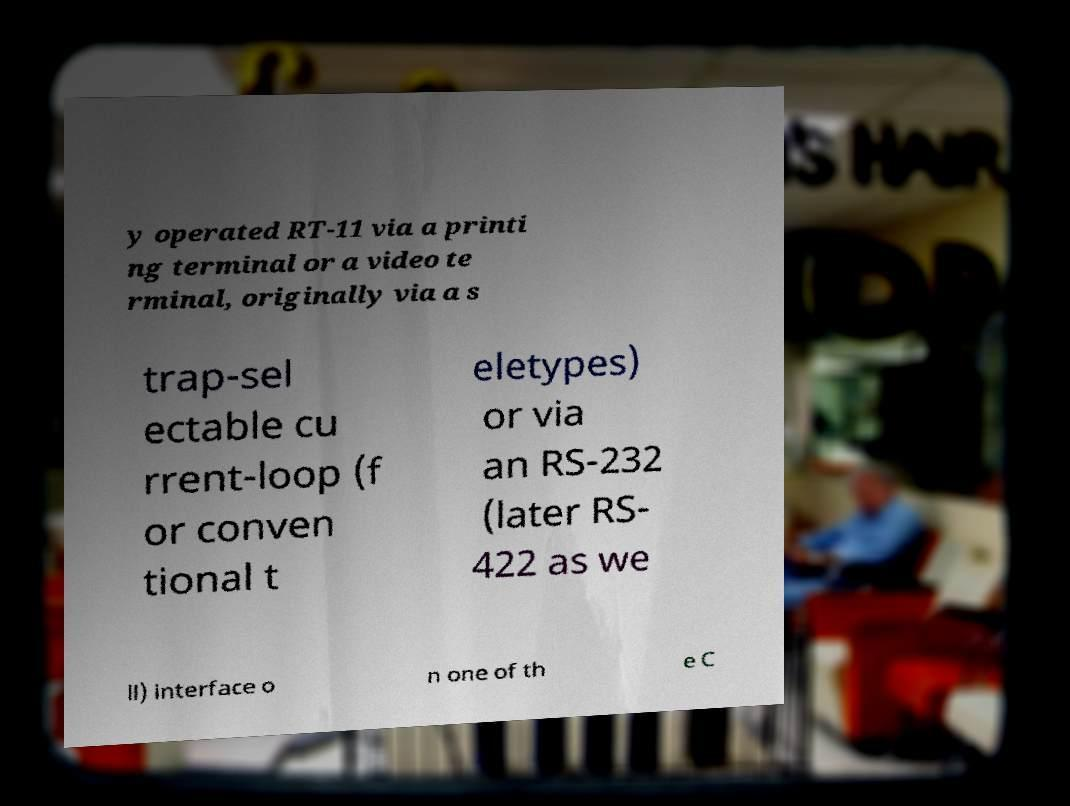There's text embedded in this image that I need extracted. Can you transcribe it verbatim? y operated RT-11 via a printi ng terminal or a video te rminal, originally via a s trap-sel ectable cu rrent-loop (f or conven tional t eletypes) or via an RS-232 (later RS- 422 as we ll) interface o n one of th e C 